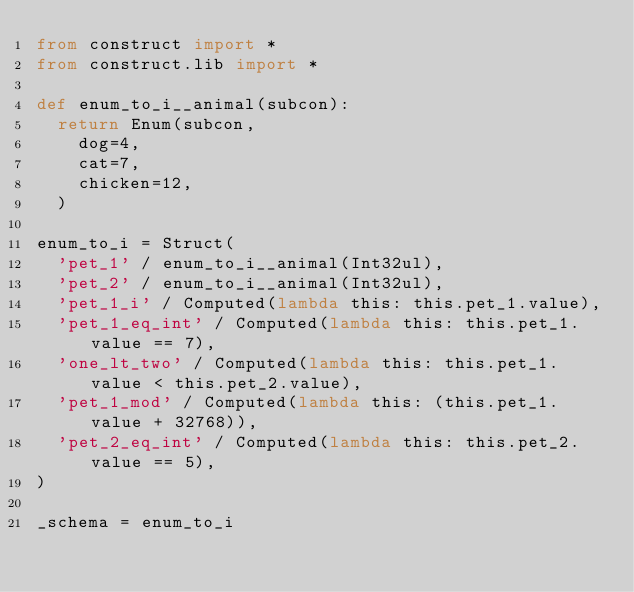Convert code to text. <code><loc_0><loc_0><loc_500><loc_500><_Python_>from construct import *
from construct.lib import *

def enum_to_i__animal(subcon):
	return Enum(subcon,
		dog=4,
		cat=7,
		chicken=12,
	)

enum_to_i = Struct(
	'pet_1' / enum_to_i__animal(Int32ul),
	'pet_2' / enum_to_i__animal(Int32ul),
	'pet_1_i' / Computed(lambda this: this.pet_1.value),
	'pet_1_eq_int' / Computed(lambda this: this.pet_1.value == 7),
	'one_lt_two' / Computed(lambda this: this.pet_1.value < this.pet_2.value),
	'pet_1_mod' / Computed(lambda this: (this.pet_1.value + 32768)),
	'pet_2_eq_int' / Computed(lambda this: this.pet_2.value == 5),
)

_schema = enum_to_i
</code> 